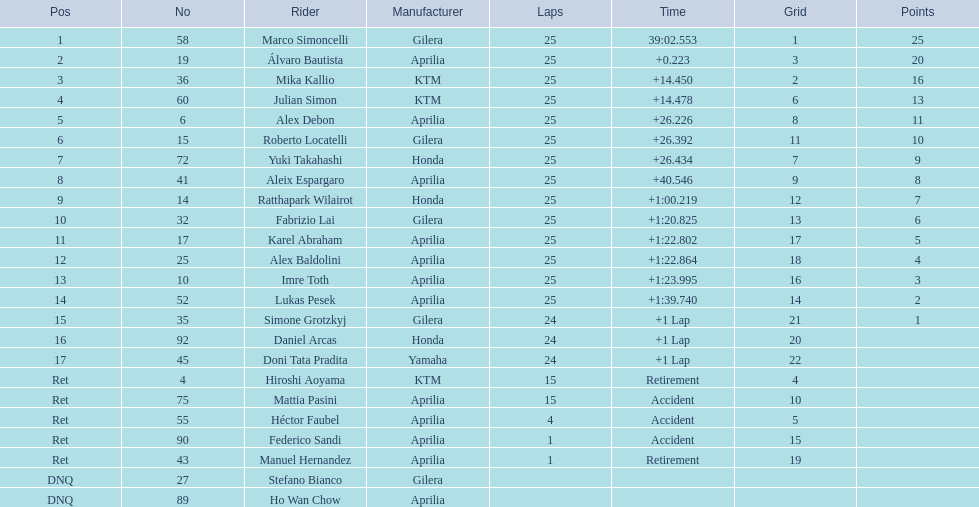What player number is marked #1 for the australian motorcycle grand prix? 58. Who is the rider that represents the #58 in the australian motorcycle grand prix? Marco Simoncelli. 